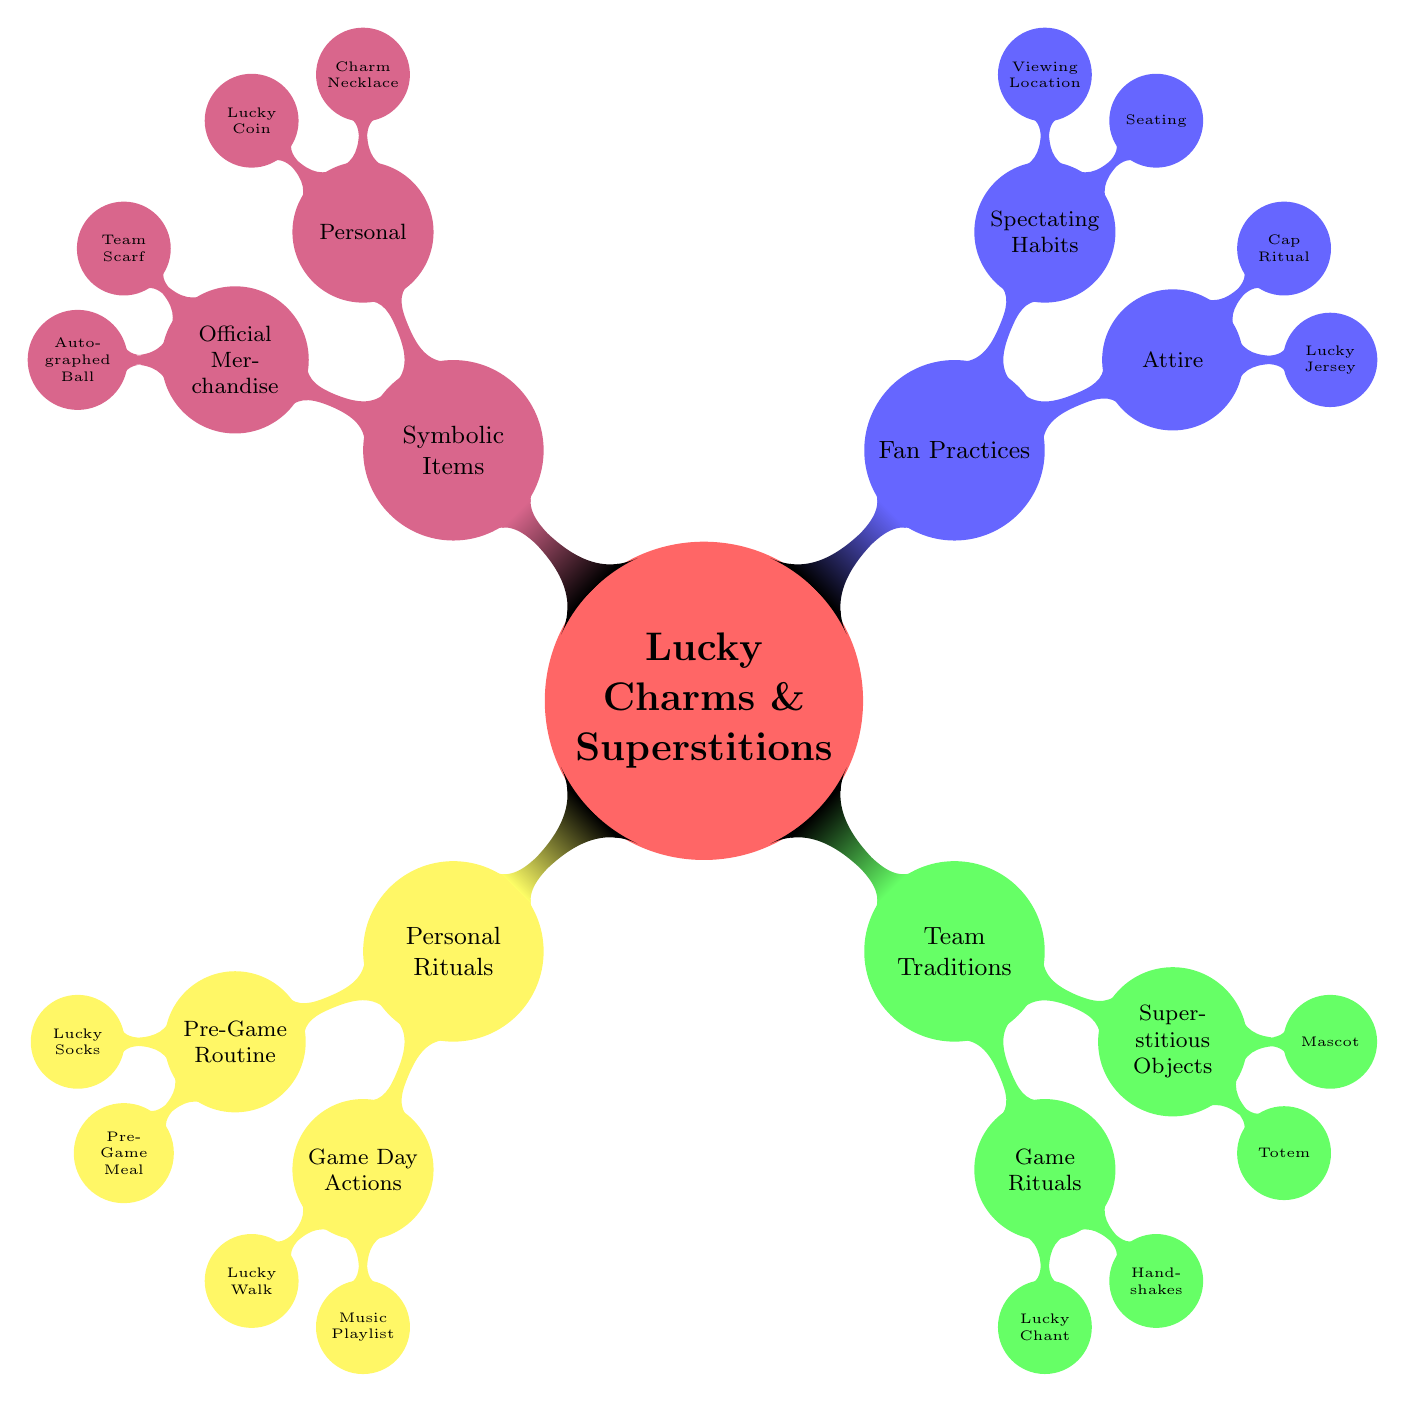What is the main topic of the mind map? The central node of the mind map represents the main topic, which is "Lucky Charms and Superstitions for Success."
Answer: Lucky Charms and Superstitions for Success How many primary categories are there in the diagram? By counting the first-level child nodes emanating from the main topic, we can see there are four main categories: Personal Rituals, Team Traditions, Fan Practices, and Symbolic Items.
Answer: 4 What is one example of a pre-game routine? Under the "Pre-Game Routine" node, the diagram lists multiple examples, one of which is "Lucky Socks."
Answer: Lucky Socks Which category includes the "Lucky Chant"? "Lucky Chant" is located within the "Game Rituals" node, which is a subcategory of the "Team Traditions" category. To find this, we look at the structure of nodes starting from Team Traditions, leading to Game Rituals, and then to the specific item "Lucky Chant."
Answer: Team Traditions What item is associated with personal symbolism in the diagram? The "Charm Necklace," mentioned under the "Personal" category in "Symbolic Items," illustrates personal symbolism due to its specific reference to the spider.
Answer: Charm Necklace How many superstitious objects does the diagram list? In the "Superstitious Objects" category, there are two items explicitly mentioned: "Totem" and "Mascot."
Answer: 2 What is a lucky action fans take regarding seating? The diagram indicates "Seating" as a practice in the "Spectating Habits" node, where fans always opt for the "same seat at the stadium."
Answer: Same seat Which node includes an example of team interaction? The "Handshakes" are illustrated in the "Game Rituals" section under "Team Traditions." It signifies an example of team interaction before games.
Answer: Game Rituals What is the specific pre-game meal mentioned in the diagram? Under the "Pre-Game Routine" node, "Pre-Game Meal" provides a specific example, which is "always eating a specific meal, like a turkey sandwich."
Answer: Pre-Game Meal 